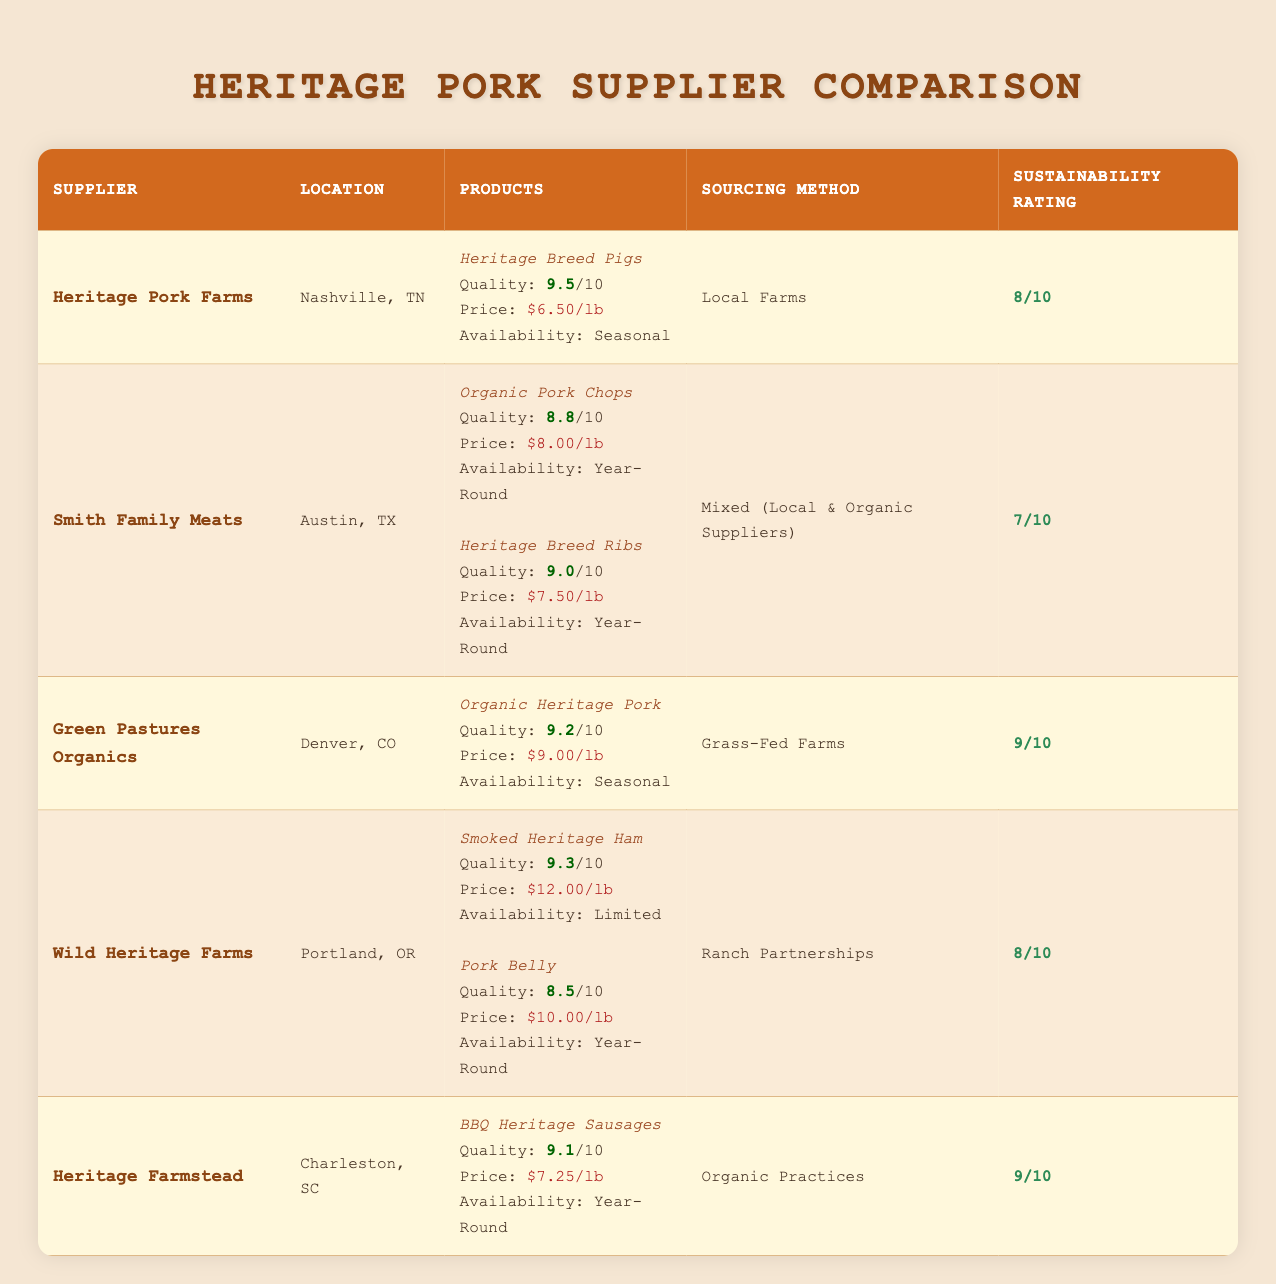What is the Quality Rating of Heritage Breed Pigs? The Quality Rating for Heritage Breed Pigs is found in the row for Heritage Pork Farms under the Products column, which states a rating of 9.5 out of 10.
Answer: 9.5 Which supplier has the highest Sustainability Rating? Looking through the table, Green Pastures Organics and Heritage Farmstead both have a Sustainability Rating of 9, which is the highest.
Answer: Green Pastures Organics and Heritage Farmstead What is the average Price per Pound of all the products listed in the table? First, we list the prices: Heritage Breed Pigs ($6.50), Organic Pork Chops ($8.00), Heritage Breed Ribs ($7.50), Organic Heritage Pork ($9.00), Smoked Heritage Ham ($12.00), Pork Belly ($10.00), BBQ Heritage Sausages ($7.25). Adding these gives 60.25, then dividing by 7 (the number of products) gives an average price of approximately $8.61.
Answer: 8.61 Does Wild Heritage Farms offer any products year-round? By reviewing the Availability section for Wild Heritage Farms, we see that Pork Belly is available year-round, making this statement true.
Answer: Yes Which supplier has products with the lowest and highest price per pound? The lowest price per pound is by Heritage Pork Farms at $6.50 for Heritage Breed Pigs, and the highest price is for Wild Heritage Farms’ Smoked Heritage Ham at $12.00.
Answer: Lowest: Heritage Pork Farms, Highest: Wild Heritage Farms What is the total Quality Rating of all products from Smith Family Meats? The two products from Smith Family Meats are Organic Pork Chops with a Quality Rating of 8.8 and Heritage Breed Ribs with a Quality Rating of 9.0. Adding these gives a total of 17.8.
Answer: 17.8 Is the availability of Green Pastures Organics' products seasonal or year-round? The Availability section in the row for Green Pastures Organics specifies that its only product, Organic Heritage Pork, is available seasonally.
Answer: Seasonal How many different products does Wild Heritage Farms offer, and what are their Quality Ratings? Wild Heritage Farms offers two products: Smoked Heritage Ham with a Quality Rating of 9.3 and Pork Belly with a Quality Rating of 8.5. Thus, the total is 2 products, and their ratings are 9.3 and 8.5.
Answer: 2 products; Ratings: 9.3, 8.5 